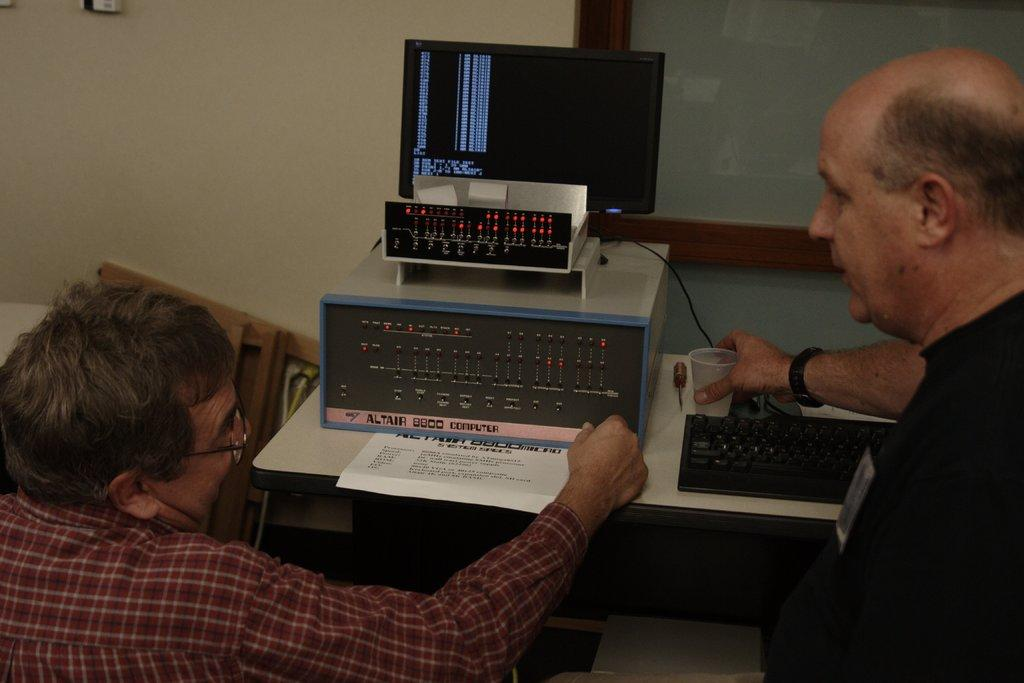<image>
Relay a brief, clear account of the picture shown. Electronic components made by Altair 8800 on a desk 